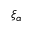<formula> <loc_0><loc_0><loc_500><loc_500>\xi _ { \alpha }</formula> 